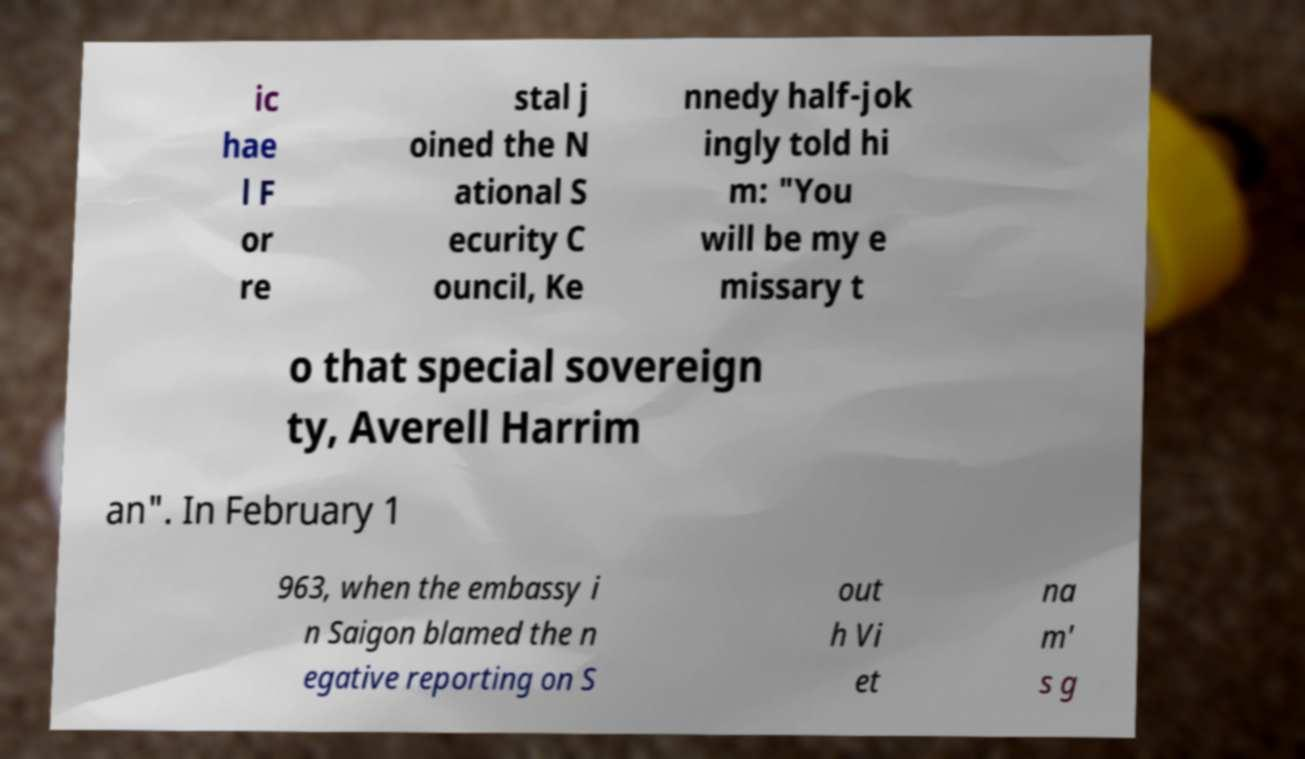Can you accurately transcribe the text from the provided image for me? ic hae l F or re stal j oined the N ational S ecurity C ouncil, Ke nnedy half-jok ingly told hi m: "You will be my e missary t o that special sovereign ty, Averell Harrim an". In February 1 963, when the embassy i n Saigon blamed the n egative reporting on S out h Vi et na m' s g 